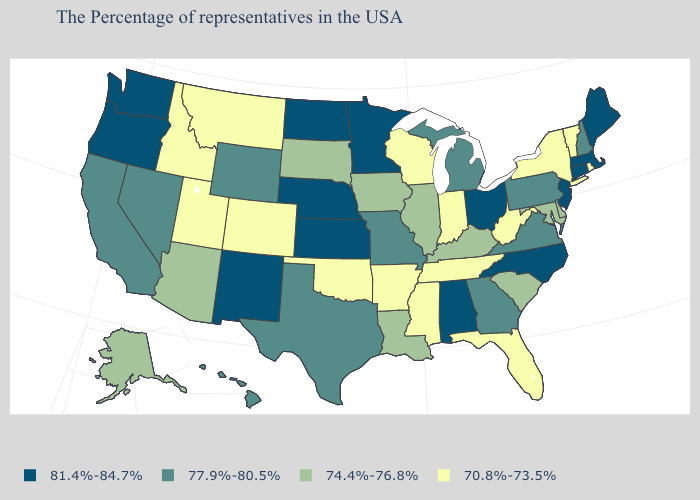What is the lowest value in the USA?
Answer briefly. 70.8%-73.5%. What is the value of Nevada?
Be succinct. 77.9%-80.5%. Name the states that have a value in the range 77.9%-80.5%?
Short answer required. New Hampshire, Pennsylvania, Virginia, Georgia, Michigan, Missouri, Texas, Wyoming, Nevada, California, Hawaii. What is the value of West Virginia?
Quick response, please. 70.8%-73.5%. What is the lowest value in the USA?
Write a very short answer. 70.8%-73.5%. Name the states that have a value in the range 70.8%-73.5%?
Keep it brief. Rhode Island, Vermont, New York, West Virginia, Florida, Indiana, Tennessee, Wisconsin, Mississippi, Arkansas, Oklahoma, Colorado, Utah, Montana, Idaho. What is the highest value in the USA?
Quick response, please. 81.4%-84.7%. Among the states that border Indiana , does Kentucky have the lowest value?
Short answer required. Yes. Does Hawaii have a higher value than New Mexico?
Short answer required. No. Which states have the lowest value in the Northeast?
Give a very brief answer. Rhode Island, Vermont, New York. What is the value of Indiana?
Answer briefly. 70.8%-73.5%. What is the value of Florida?
Short answer required. 70.8%-73.5%. Name the states that have a value in the range 74.4%-76.8%?
Be succinct. Delaware, Maryland, South Carolina, Kentucky, Illinois, Louisiana, Iowa, South Dakota, Arizona, Alaska. Does the first symbol in the legend represent the smallest category?
Write a very short answer. No. 